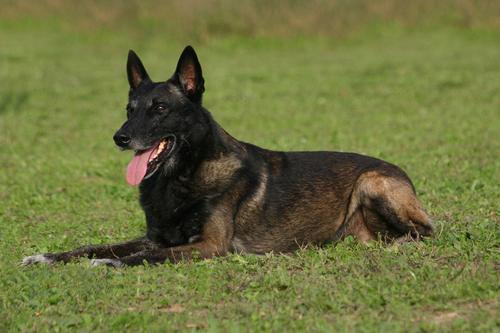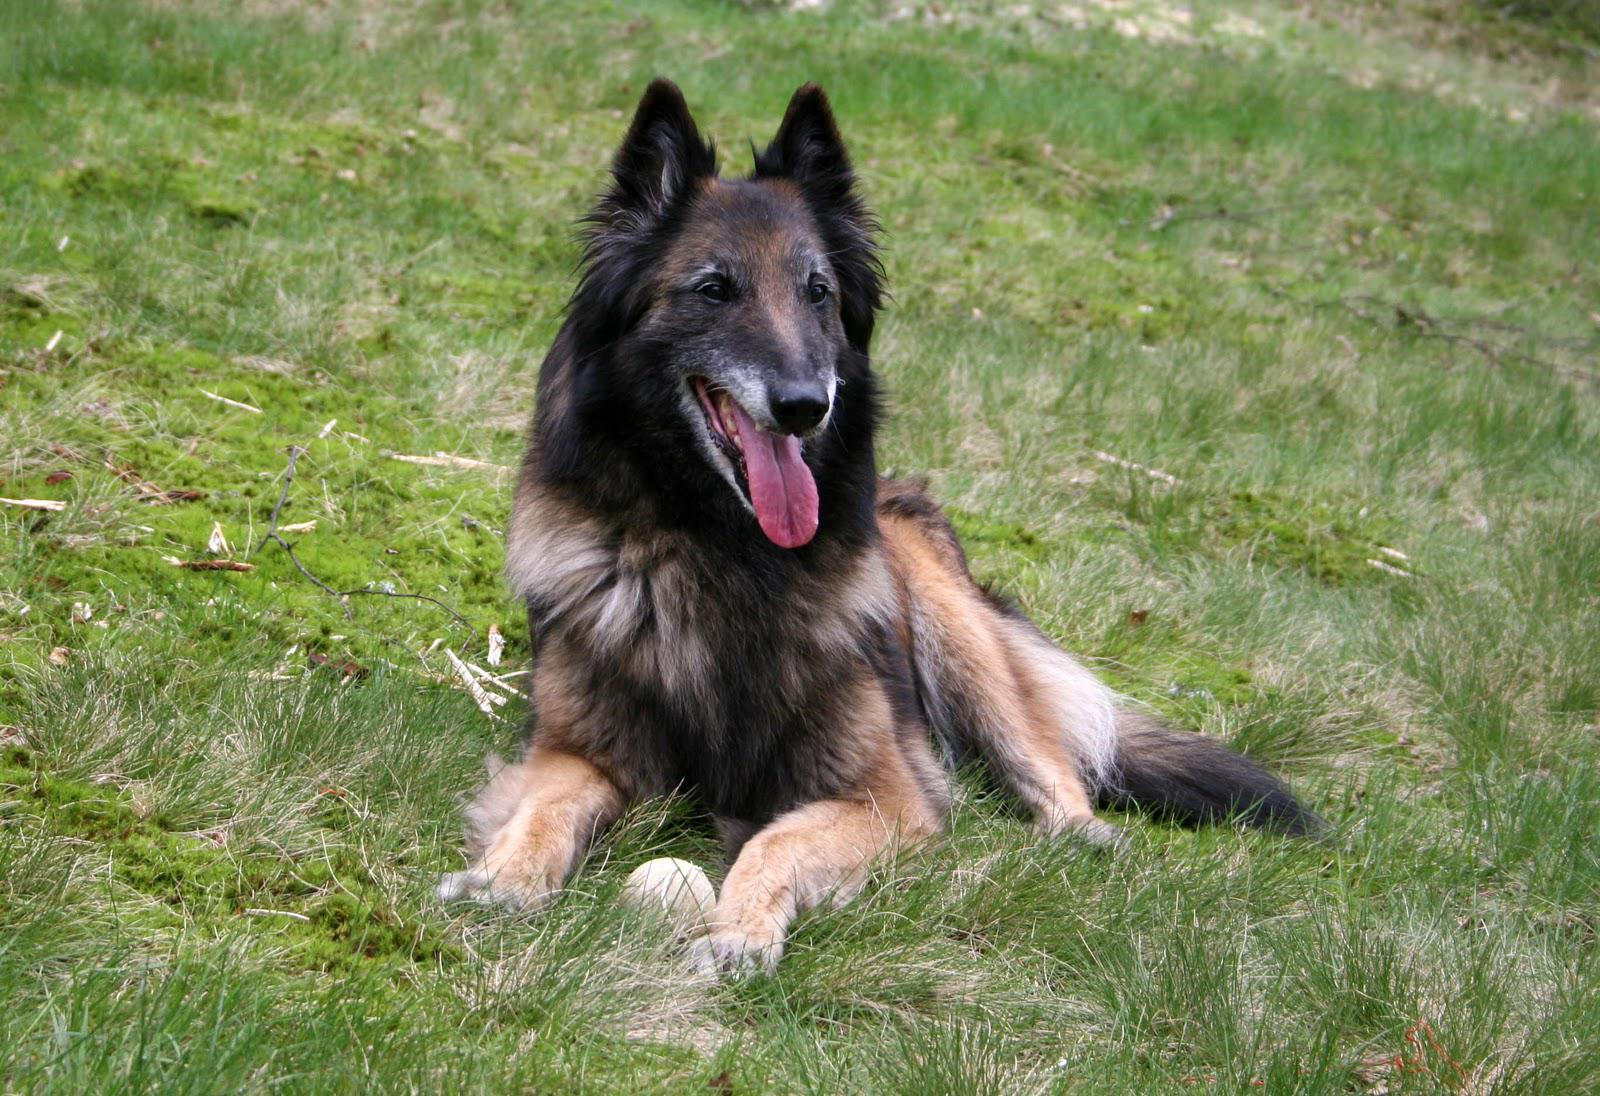The first image is the image on the left, the second image is the image on the right. Examine the images to the left and right. Is the description "At least one dog has a red collar." accurate? Answer yes or no. No. 